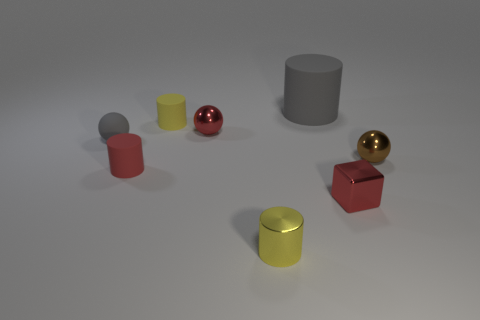Subtract all small cylinders. How many cylinders are left? 1 Subtract all red cubes. How many yellow cylinders are left? 2 Subtract all gray cylinders. How many cylinders are left? 3 Subtract 1 cylinders. How many cylinders are left? 3 Add 1 cyan shiny blocks. How many objects exist? 9 Subtract all spheres. How many objects are left? 5 Subtract all green cylinders. Subtract all red cubes. How many cylinders are left? 4 Add 1 brown metallic objects. How many brown metallic objects are left? 2 Add 1 tiny cubes. How many tiny cubes exist? 2 Subtract 0 yellow blocks. How many objects are left? 8 